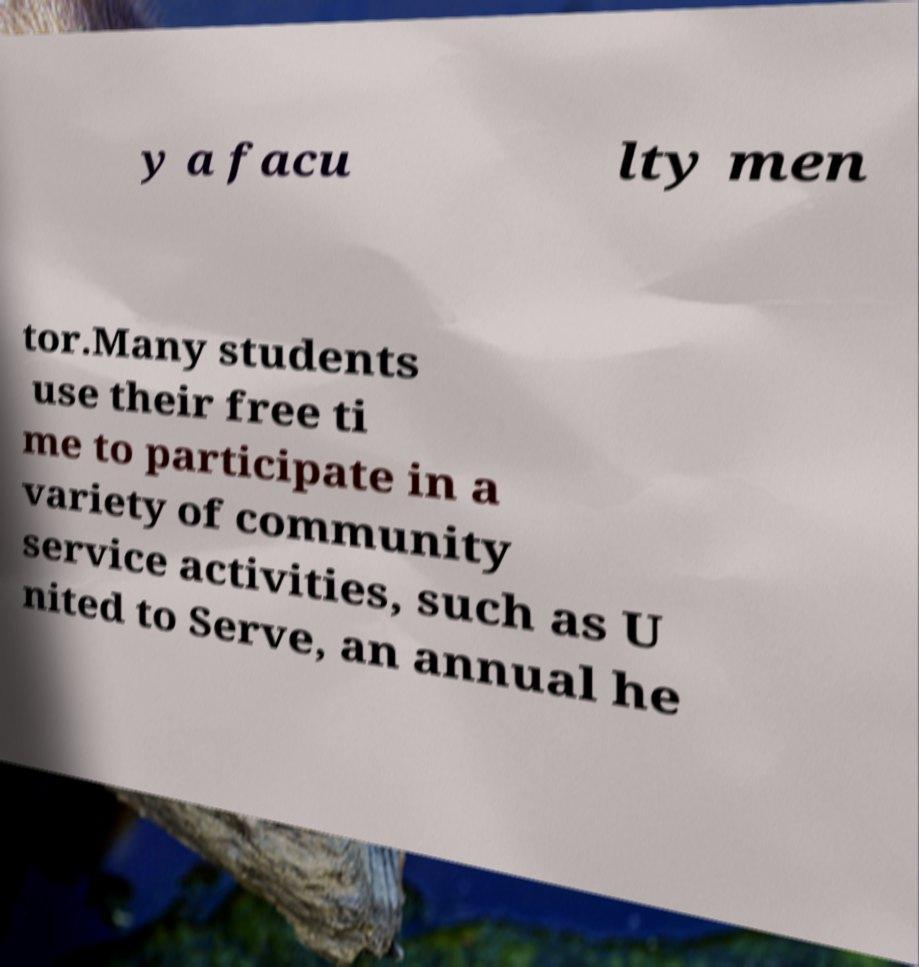Please identify and transcribe the text found in this image. y a facu lty men tor.Many students use their free ti me to participate in a variety of community service activities, such as U nited to Serve, an annual he 